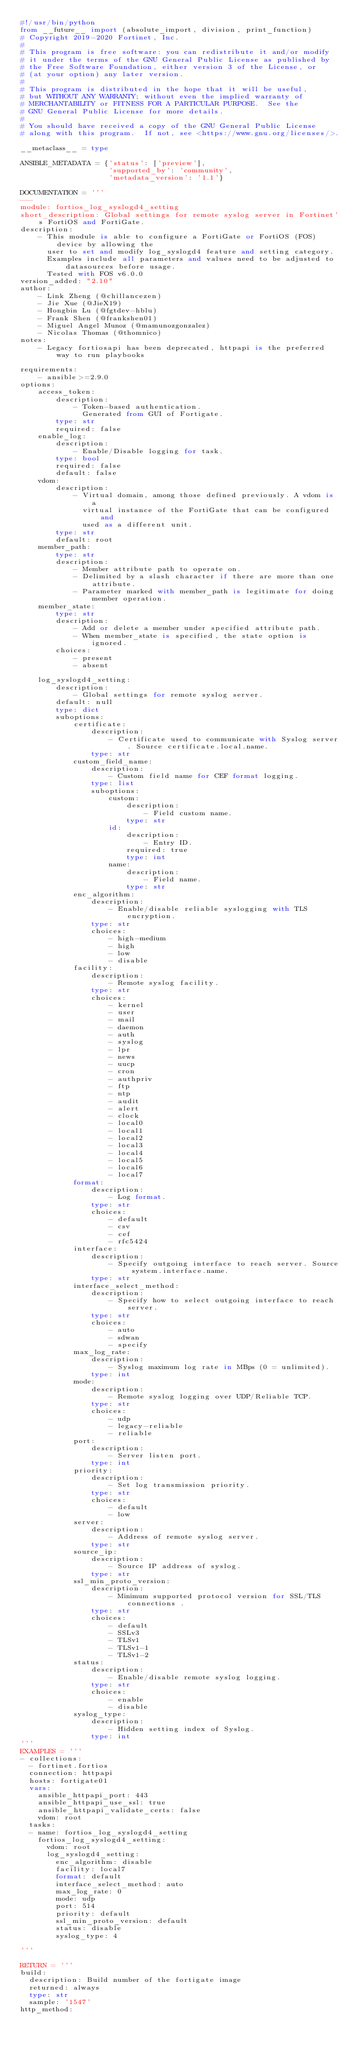Convert code to text. <code><loc_0><loc_0><loc_500><loc_500><_Python_>#!/usr/bin/python
from __future__ import (absolute_import, division, print_function)
# Copyright 2019-2020 Fortinet, Inc.
#
# This program is free software: you can redistribute it and/or modify
# it under the terms of the GNU General Public License as published by
# the Free Software Foundation, either version 3 of the License, or
# (at your option) any later version.
#
# This program is distributed in the hope that it will be useful,
# but WITHOUT ANY WARRANTY; without even the implied warranty of
# MERCHANTABILITY or FITNESS FOR A PARTICULAR PURPOSE.  See the
# GNU General Public License for more details.
#
# You should have received a copy of the GNU General Public License
# along with this program.  If not, see <https://www.gnu.org/licenses/>.

__metaclass__ = type

ANSIBLE_METADATA = {'status': ['preview'],
                    'supported_by': 'community',
                    'metadata_version': '1.1'}

DOCUMENTATION = '''
---
module: fortios_log_syslogd4_setting
short_description: Global settings for remote syslog server in Fortinet's FortiOS and FortiGate.
description:
    - This module is able to configure a FortiGate or FortiOS (FOS) device by allowing the
      user to set and modify log_syslogd4 feature and setting category.
      Examples include all parameters and values need to be adjusted to datasources before usage.
      Tested with FOS v6.0.0
version_added: "2.10"
author:
    - Link Zheng (@chillancezen)
    - Jie Xue (@JieX19)
    - Hongbin Lu (@fgtdev-hblu)
    - Frank Shen (@frankshen01)
    - Miguel Angel Munoz (@mamunozgonzalez)
    - Nicolas Thomas (@thomnico)
notes:
    - Legacy fortiosapi has been deprecated, httpapi is the preferred way to run playbooks

requirements:
    - ansible>=2.9.0
options:
    access_token:
        description:
            - Token-based authentication.
              Generated from GUI of Fortigate.
        type: str
        required: false
    enable_log:
        description:
            - Enable/Disable logging for task.
        type: bool
        required: false
        default: false
    vdom:
        description:
            - Virtual domain, among those defined previously. A vdom is a
              virtual instance of the FortiGate that can be configured and
              used as a different unit.
        type: str
        default: root
    member_path:
        type: str
        description:
            - Member attribute path to operate on.
            - Delimited by a slash character if there are more than one attribute.
            - Parameter marked with member_path is legitimate for doing member operation.
    member_state:
        type: str
        description:
            - Add or delete a member under specified attribute path.
            - When member_state is specified, the state option is ignored.
        choices:
            - present
            - absent

    log_syslogd4_setting:
        description:
            - Global settings for remote syslog server.
        default: null
        type: dict
        suboptions:
            certificate:
                description:
                    - Certificate used to communicate with Syslog server. Source certificate.local.name.
                type: str
            custom_field_name:
                description:
                    - Custom field name for CEF format logging.
                type: list
                suboptions:
                    custom:
                        description:
                            - Field custom name.
                        type: str
                    id:
                        description:
                            - Entry ID.
                        required: true
                        type: int
                    name:
                        description:
                            - Field name.
                        type: str
            enc_algorithm:
                description:
                    - Enable/disable reliable syslogging with TLS encryption.
                type: str
                choices:
                    - high-medium
                    - high
                    - low
                    - disable
            facility:
                description:
                    - Remote syslog facility.
                type: str
                choices:
                    - kernel
                    - user
                    - mail
                    - daemon
                    - auth
                    - syslog
                    - lpr
                    - news
                    - uucp
                    - cron
                    - authpriv
                    - ftp
                    - ntp
                    - audit
                    - alert
                    - clock
                    - local0
                    - local1
                    - local2
                    - local3
                    - local4
                    - local5
                    - local6
                    - local7
            format:
                description:
                    - Log format.
                type: str
                choices:
                    - default
                    - csv
                    - cef
                    - rfc5424
            interface:
                description:
                    - Specify outgoing interface to reach server. Source system.interface.name.
                type: str
            interface_select_method:
                description:
                    - Specify how to select outgoing interface to reach server.
                type: str
                choices:
                    - auto
                    - sdwan
                    - specify
            max_log_rate:
                description:
                    - Syslog maximum log rate in MBps (0 = unlimited).
                type: int
            mode:
                description:
                    - Remote syslog logging over UDP/Reliable TCP.
                type: str
                choices:
                    - udp
                    - legacy-reliable
                    - reliable
            port:
                description:
                    - Server listen port.
                type: int
            priority:
                description:
                    - Set log transmission priority.
                type: str
                choices:
                    - default
                    - low
            server:
                description:
                    - Address of remote syslog server.
                type: str
            source_ip:
                description:
                    - Source IP address of syslog.
                type: str
            ssl_min_proto_version:
                description:
                    - Minimum supported protocol version for SSL/TLS connections .
                type: str
                choices:
                    - default
                    - SSLv3
                    - TLSv1
                    - TLSv1-1
                    - TLSv1-2
            status:
                description:
                    - Enable/disable remote syslog logging.
                type: str
                choices:
                    - enable
                    - disable
            syslog_type:
                description:
                    - Hidden setting index of Syslog.
                type: int
'''
EXAMPLES = '''
- collections:
  - fortinet.fortios
  connection: httpapi
  hosts: fortigate01
  vars:
    ansible_httpapi_port: 443
    ansible_httpapi_use_ssl: true
    ansible_httpapi_validate_certs: false
    vdom: root
  tasks:
  - name: fortios_log_syslogd4_setting
    fortios_log_syslogd4_setting:
      vdom: root
      log_syslogd4_setting:
        enc_algorithm: disable
        facility: local7
        format: default
        interface_select_method: auto
        max_log_rate: 0
        mode: udp
        port: 514
        priority: default
        ssl_min_proto_version: default
        status: disable
        syslog_type: 4

'''

RETURN = '''
build:
  description: Build number of the fortigate image
  returned: always
  type: str
  sample: '1547'
http_method:</code> 